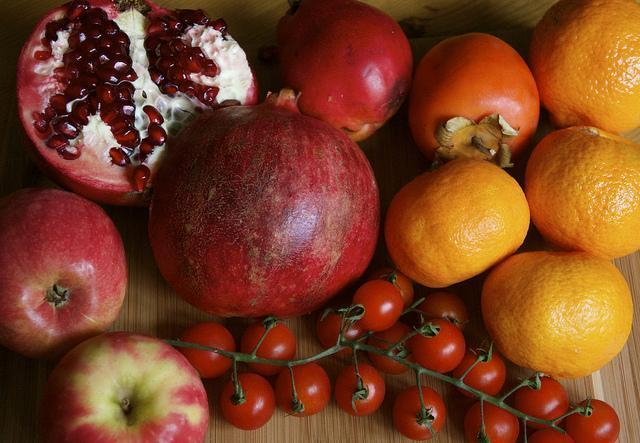How many oranges are there?
Give a very brief answer. 4. How many apples can be seen?
Give a very brief answer. 2. 